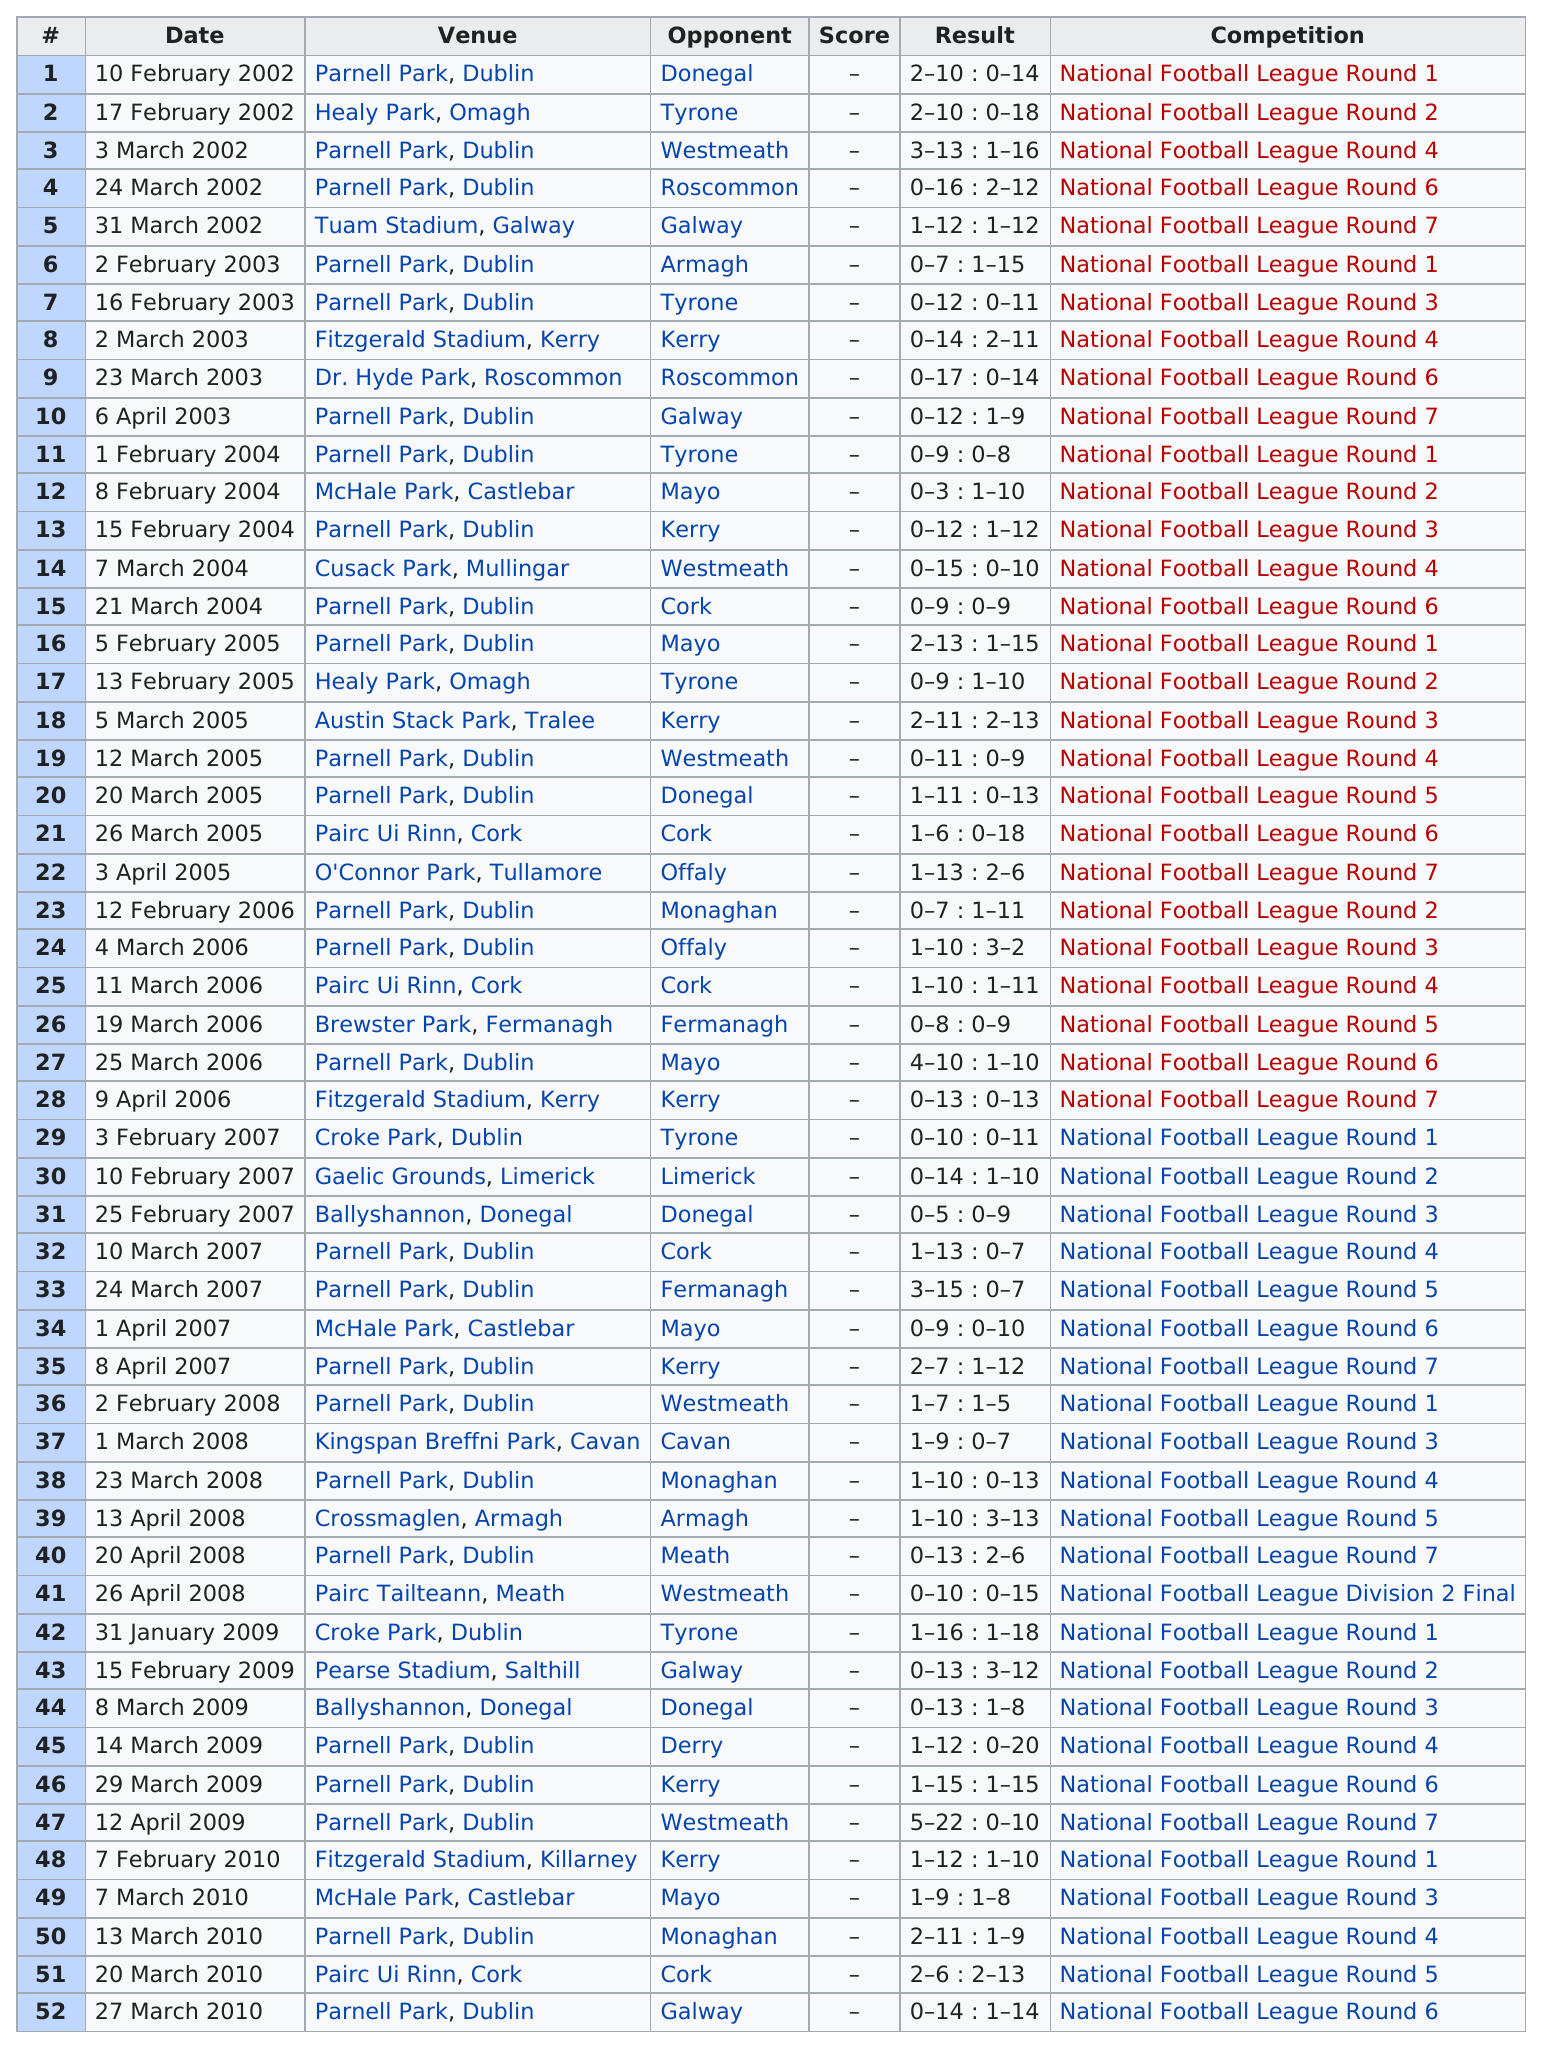Give some essential details in this illustration. In 2005, the total number of appearances was 7. On February 13th, 2005, the final score of 0-9 was reached in addition to March 12th. 